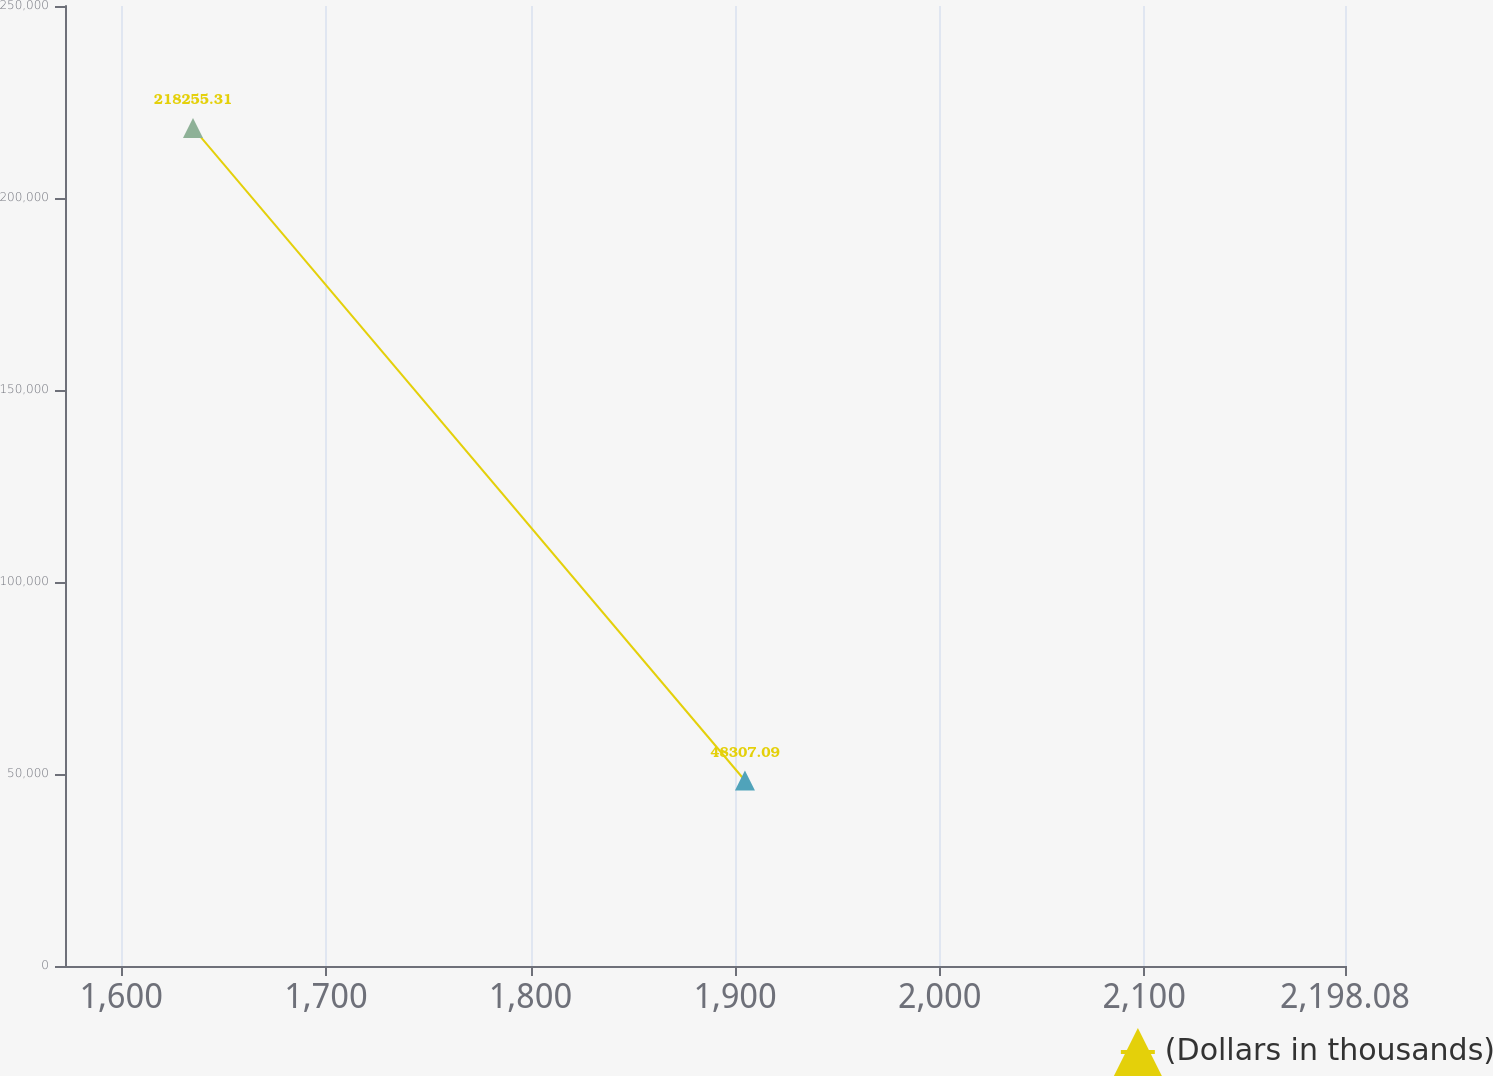Convert chart to OTSL. <chart><loc_0><loc_0><loc_500><loc_500><line_chart><ecel><fcel>(Dollars in thousands)<nl><fcel>1635.04<fcel>218255<nl><fcel>1904.8<fcel>48307.1<nl><fcel>2203.29<fcel>133281<nl><fcel>2260.64<fcel>898048<nl></chart> 